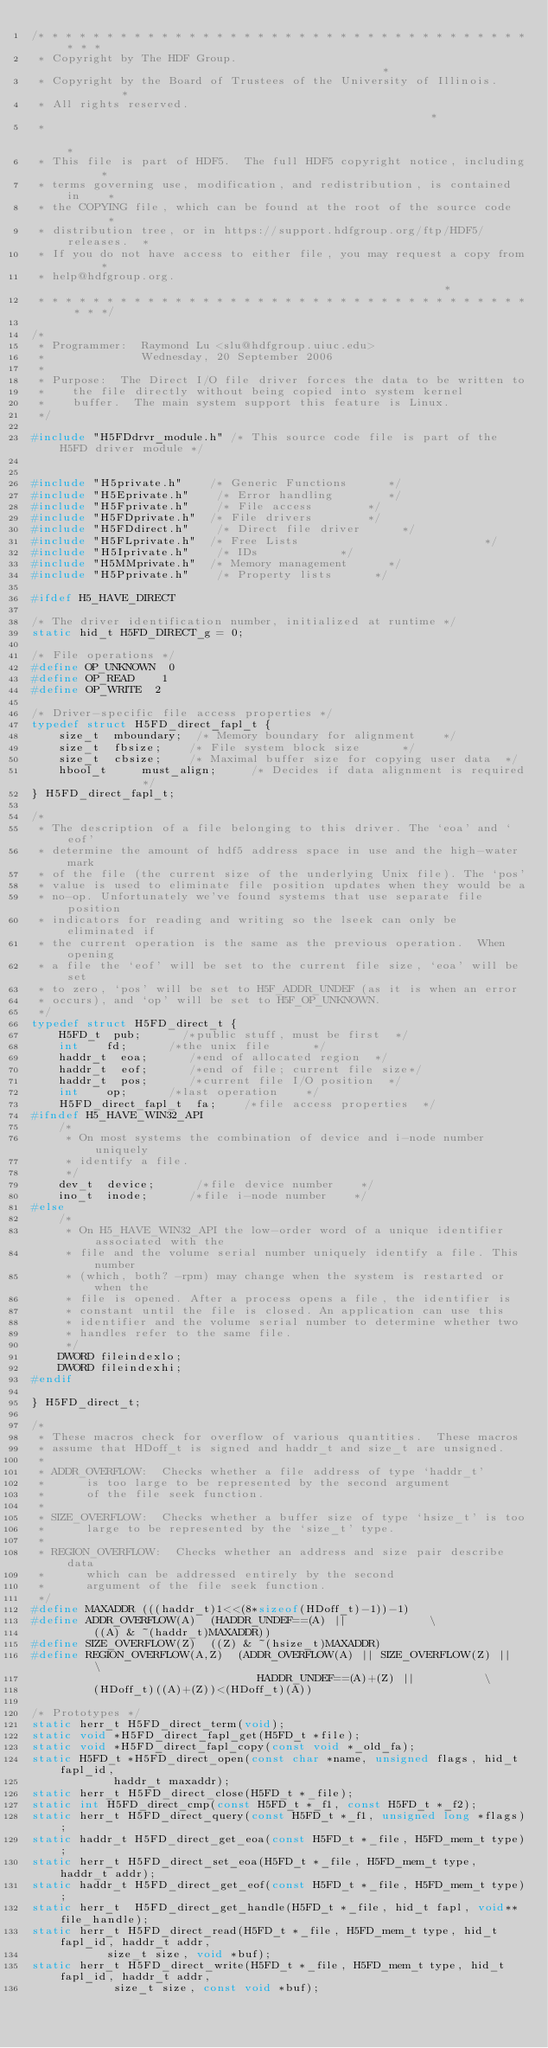Convert code to text. <code><loc_0><loc_0><loc_500><loc_500><_C_>/* * * * * * * * * * * * * * * * * * * * * * * * * * * * * * * * * * * * * * *
 * Copyright by The HDF Group.                                               *
 * Copyright by the Board of Trustees of the University of Illinois.         *
 * All rights reserved.                                                      *
 *                                                                           *
 * This file is part of HDF5.  The full HDF5 copyright notice, including     *
 * terms governing use, modification, and redistribution, is contained in    *
 * the COPYING file, which can be found at the root of the source code       *
 * distribution tree, or in https://support.hdfgroup.org/ftp/HDF5/releases.  *
 * If you do not have access to either file, you may request a copy from     *
 * help@hdfgroup.org.                                                        *
 * * * * * * * * * * * * * * * * * * * * * * * * * * * * * * * * * * * * * * */

/*
 * Programmer:  Raymond Lu <slu@hdfgroup.uiuc.edu>
 *              Wednesday, 20 September 2006
 *
 * Purpose:  The Direct I/O file driver forces the data to be written to
 *    the file directly without being copied into system kernel
 *    buffer.  The main system support this feature is Linux.
 */

#include "H5FDdrvr_module.h" /* This source code file is part of the H5FD driver module */


#include "H5private.h"    /* Generic Functions      */
#include "H5Eprivate.h"    /* Error handling        */
#include "H5Fprivate.h"    /* File access        */
#include "H5FDprivate.h"  /* File drivers        */
#include "H5FDdirect.h"    /* Direct file driver      */
#include "H5FLprivate.h"  /* Free Lists                           */
#include "H5Iprivate.h"    /* IDs            */
#include "H5MMprivate.h"  /* Memory management      */
#include "H5Pprivate.h"    /* Property lists      */

#ifdef H5_HAVE_DIRECT

/* The driver identification number, initialized at runtime */
static hid_t H5FD_DIRECT_g = 0;

/* File operations */
#define OP_UNKNOWN  0
#define OP_READ    1
#define OP_WRITE  2

/* Driver-specific file access properties */
typedef struct H5FD_direct_fapl_t {
    size_t  mboundary;  /* Memory boundary for alignment    */
    size_t  fbsize;    /* File system block size      */
    size_t  cbsize;    /* Maximal buffer size for copying user data  */
    hbool_t     must_align;     /* Decides if data alignment is required        */
} H5FD_direct_fapl_t;

/*
 * The description of a file belonging to this driver. The `eoa' and `eof'
 * determine the amount of hdf5 address space in use and the high-water mark
 * of the file (the current size of the underlying Unix file). The `pos'
 * value is used to eliminate file position updates when they would be a
 * no-op. Unfortunately we've found systems that use separate file position
 * indicators for reading and writing so the lseek can only be eliminated if
 * the current operation is the same as the previous operation.  When opening
 * a file the `eof' will be set to the current file size, `eoa' will be set
 * to zero, `pos' will be set to H5F_ADDR_UNDEF (as it is when an error
 * occurs), and `op' will be set to H5F_OP_UNKNOWN.
 */
typedef struct H5FD_direct_t {
    H5FD_t  pub;      /*public stuff, must be first  */
    int    fd;      /*the unix file      */
    haddr_t  eoa;      /*end of allocated region  */
    haddr_t  eof;      /*end of file; current file size*/
    haddr_t  pos;      /*current file I/O position  */
    int    op;      /*last operation    */
    H5FD_direct_fapl_t  fa;    /*file access properties  */
#ifndef H5_HAVE_WIN32_API
    /*
     * On most systems the combination of device and i-node number uniquely
     * identify a file.
     */
    dev_t  device;      /*file device number    */
    ino_t  inode;      /*file i-node number    */
#else
    /*
     * On H5_HAVE_WIN32_API the low-order word of a unique identifier associated with the
     * file and the volume serial number uniquely identify a file. This number
     * (which, both? -rpm) may change when the system is restarted or when the
     * file is opened. After a process opens a file, the identifier is
     * constant until the file is closed. An application can use this
     * identifier and the volume serial number to determine whether two
     * handles refer to the same file.
     */
    DWORD fileindexlo;
    DWORD fileindexhi;
#endif

} H5FD_direct_t;

/*
 * These macros check for overflow of various quantities.  These macros
 * assume that HDoff_t is signed and haddr_t and size_t are unsigned.
 *
 * ADDR_OVERFLOW:  Checks whether a file address of type `haddr_t'
 *      is too large to be represented by the second argument
 *      of the file seek function.
 *
 * SIZE_OVERFLOW:  Checks whether a buffer size of type `hsize_t' is too
 *      large to be represented by the `size_t' type.
 *
 * REGION_OVERFLOW:  Checks whether an address and size pair describe data
 *      which can be addressed entirely by the second
 *      argument of the file seek function.
 */
#define MAXADDR (((haddr_t)1<<(8*sizeof(HDoff_t)-1))-1)
#define ADDR_OVERFLOW(A)  (HADDR_UNDEF==(A) ||            \
         ((A) & ~(haddr_t)MAXADDR))
#define SIZE_OVERFLOW(Z)  ((Z) & ~(hsize_t)MAXADDR)
#define REGION_OVERFLOW(A,Z)  (ADDR_OVERFLOW(A) || SIZE_OVERFLOW(Z) ||      \
                                 HADDR_UNDEF==(A)+(Z) ||          \
         (HDoff_t)((A)+(Z))<(HDoff_t)(A))

/* Prototypes */
static herr_t H5FD_direct_term(void);
static void *H5FD_direct_fapl_get(H5FD_t *file);
static void *H5FD_direct_fapl_copy(const void *_old_fa);
static H5FD_t *H5FD_direct_open(const char *name, unsigned flags, hid_t fapl_id,
            haddr_t maxaddr);
static herr_t H5FD_direct_close(H5FD_t *_file);
static int H5FD_direct_cmp(const H5FD_t *_f1, const H5FD_t *_f2);
static herr_t H5FD_direct_query(const H5FD_t *_f1, unsigned long *flags);
static haddr_t H5FD_direct_get_eoa(const H5FD_t *_file, H5FD_mem_t type);
static herr_t H5FD_direct_set_eoa(H5FD_t *_file, H5FD_mem_t type, haddr_t addr);
static haddr_t H5FD_direct_get_eof(const H5FD_t *_file, H5FD_mem_t type);
static herr_t  H5FD_direct_get_handle(H5FD_t *_file, hid_t fapl, void** file_handle);
static herr_t H5FD_direct_read(H5FD_t *_file, H5FD_mem_t type, hid_t fapl_id, haddr_t addr,
           size_t size, void *buf);
static herr_t H5FD_direct_write(H5FD_t *_file, H5FD_mem_t type, hid_t fapl_id, haddr_t addr,
            size_t size, const void *buf);</code> 